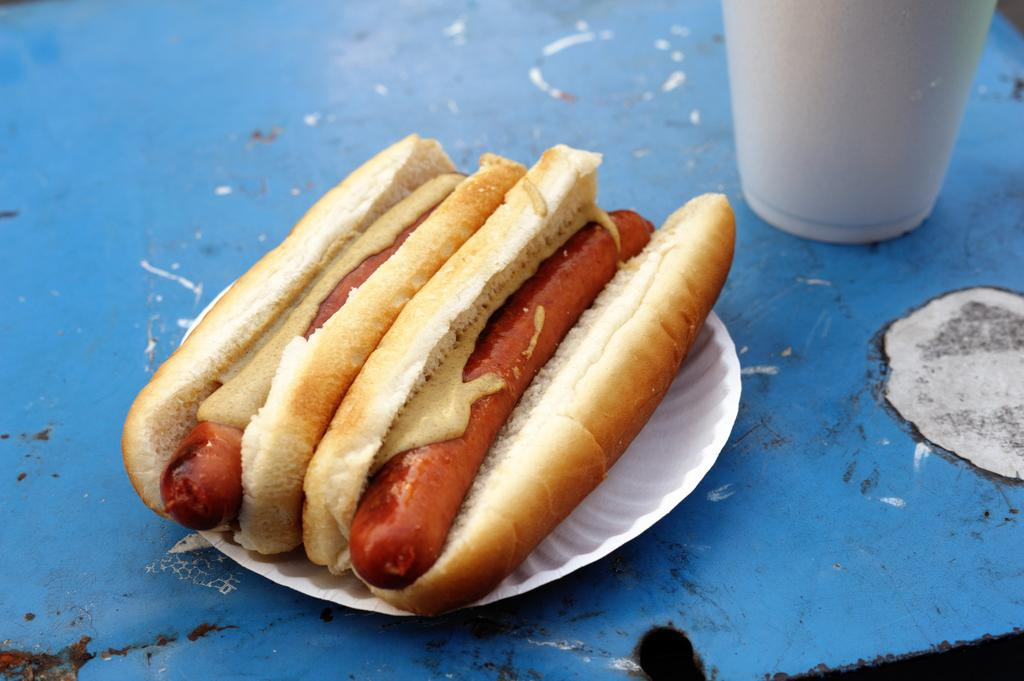What is the main subject of the image? The main subject of the image is food. How is the food being served or presented? The food is in a paper plate. Are there any other objects visible in the image? Yes, there is a white-colored glass in the image. How much money is visible in the image? There is no money visible in the image; it only features food in a paper plate and a white-colored glass. 